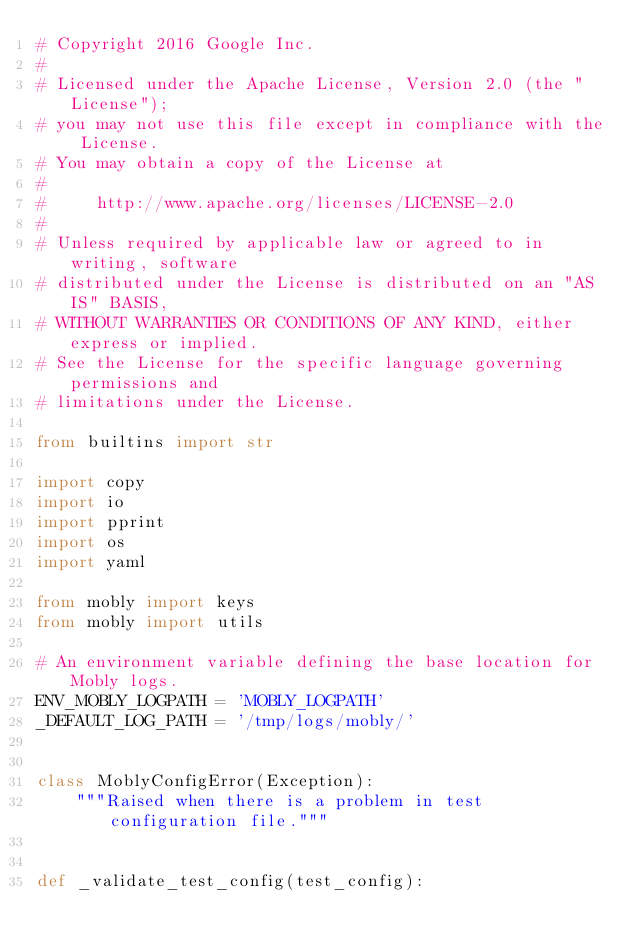<code> <loc_0><loc_0><loc_500><loc_500><_Python_># Copyright 2016 Google Inc.
#
# Licensed under the Apache License, Version 2.0 (the "License");
# you may not use this file except in compliance with the License.
# You may obtain a copy of the License at
#
#     http://www.apache.org/licenses/LICENSE-2.0
#
# Unless required by applicable law or agreed to in writing, software
# distributed under the License is distributed on an "AS IS" BASIS,
# WITHOUT WARRANTIES OR CONDITIONS OF ANY KIND, either express or implied.
# See the License for the specific language governing permissions and
# limitations under the License.

from builtins import str

import copy
import io
import pprint
import os
import yaml

from mobly import keys
from mobly import utils

# An environment variable defining the base location for Mobly logs.
ENV_MOBLY_LOGPATH = 'MOBLY_LOGPATH'
_DEFAULT_LOG_PATH = '/tmp/logs/mobly/'


class MoblyConfigError(Exception):
    """Raised when there is a problem in test configuration file."""


def _validate_test_config(test_config):</code> 